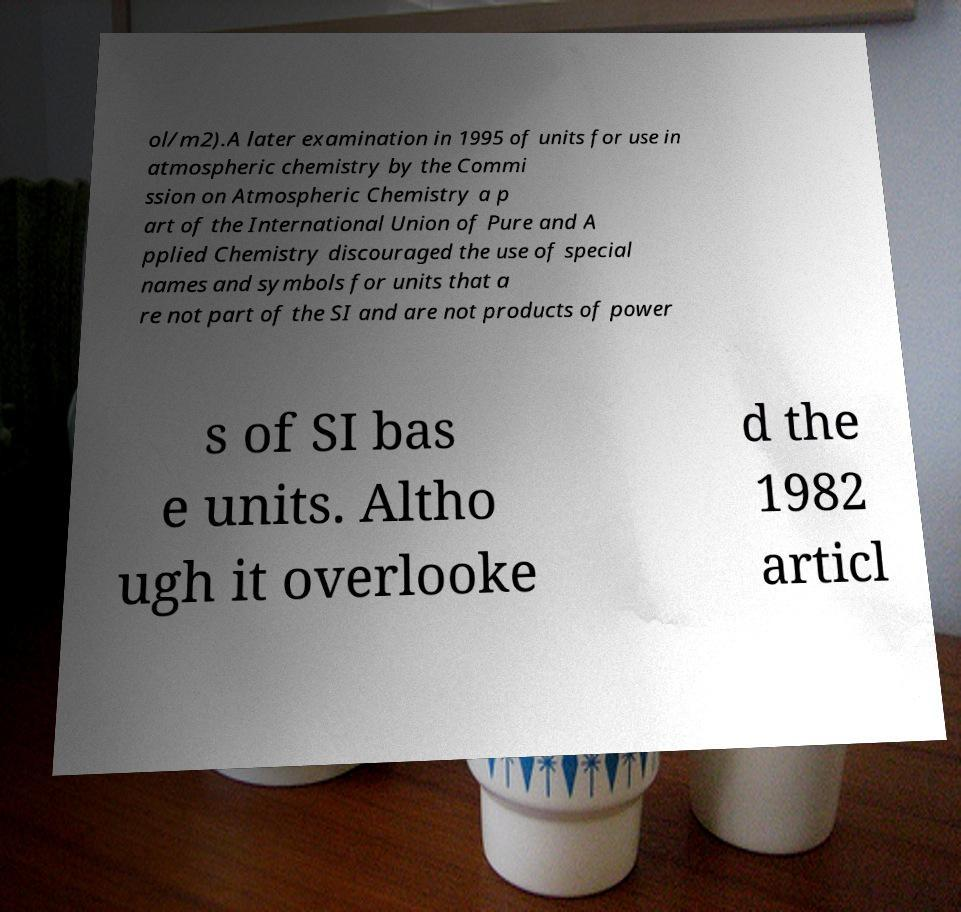I need the written content from this picture converted into text. Can you do that? ol/m2).A later examination in 1995 of units for use in atmospheric chemistry by the Commi ssion on Atmospheric Chemistry a p art of the International Union of Pure and A pplied Chemistry discouraged the use of special names and symbols for units that a re not part of the SI and are not products of power s of SI bas e units. Altho ugh it overlooke d the 1982 articl 